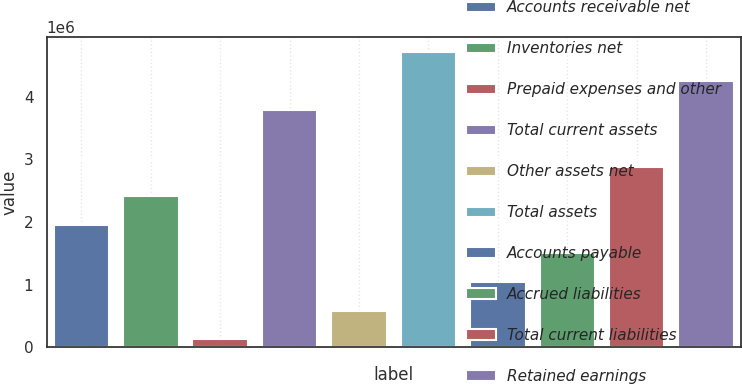Convert chart to OTSL. <chart><loc_0><loc_0><loc_500><loc_500><bar_chart><fcel>Accounts receivable net<fcel>Inventories net<fcel>Prepaid expenses and other<fcel>Total current assets<fcel>Other assets net<fcel>Total assets<fcel>Accounts payable<fcel>Accrued liabilities<fcel>Total current liabilities<fcel>Retained earnings<nl><fcel>1.95944e+06<fcel>2.41886e+06<fcel>121796<fcel>3.79709e+06<fcel>581208<fcel>4.71592e+06<fcel>1.04062e+06<fcel>1.50003e+06<fcel>2.87827e+06<fcel>4.2565e+06<nl></chart> 